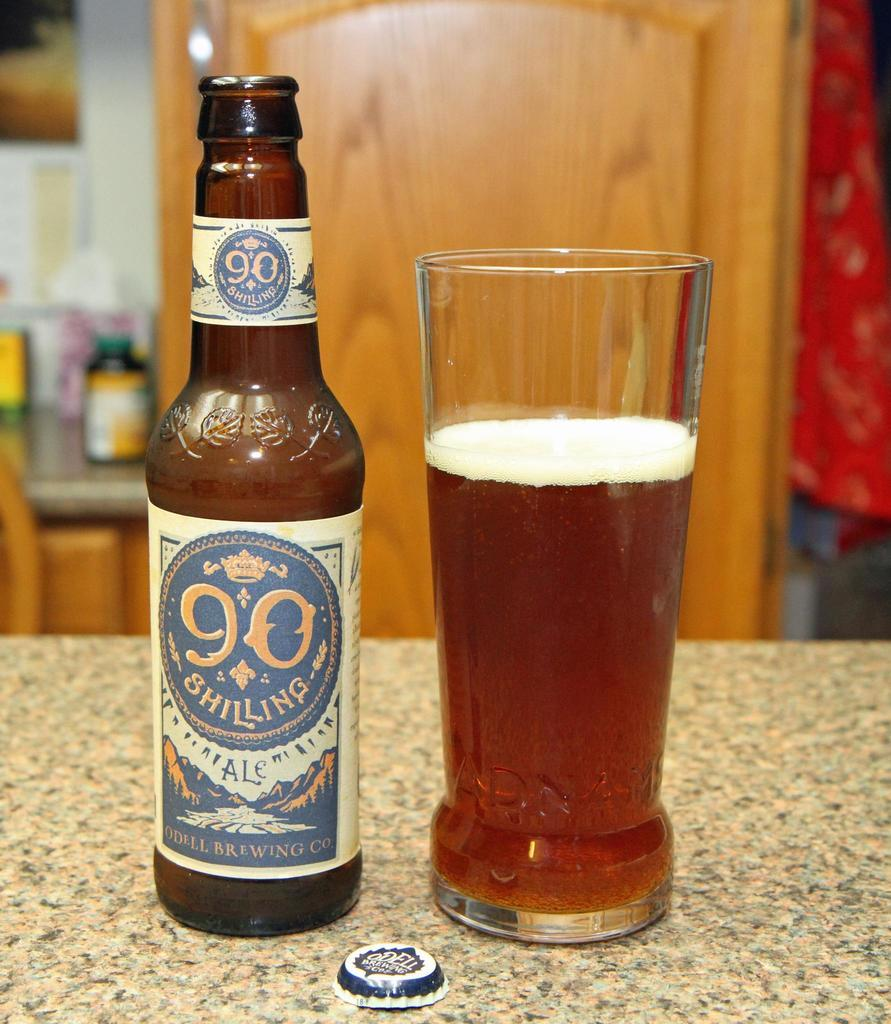<image>
Relay a brief, clear account of the picture shown. A beer from Odell Brewing Co has been poured into a glass. 